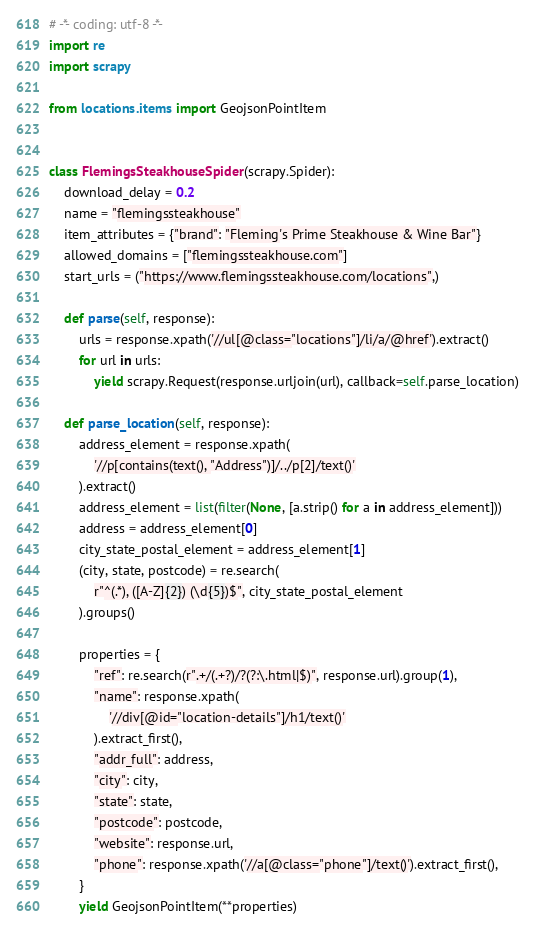<code> <loc_0><loc_0><loc_500><loc_500><_Python_># -*- coding: utf-8 -*-
import re
import scrapy

from locations.items import GeojsonPointItem


class FlemingsSteakhouseSpider(scrapy.Spider):
    download_delay = 0.2
    name = "flemingssteakhouse"
    item_attributes = {"brand": "Fleming's Prime Steakhouse & Wine Bar"}
    allowed_domains = ["flemingssteakhouse.com"]
    start_urls = ("https://www.flemingssteakhouse.com/locations",)

    def parse(self, response):
        urls = response.xpath('//ul[@class="locations"]/li/a/@href').extract()
        for url in urls:
            yield scrapy.Request(response.urljoin(url), callback=self.parse_location)

    def parse_location(self, response):
        address_element = response.xpath(
            '//p[contains(text(), "Address")]/../p[2]/text()'
        ).extract()
        address_element = list(filter(None, [a.strip() for a in address_element]))
        address = address_element[0]
        city_state_postal_element = address_element[1]
        (city, state, postcode) = re.search(
            r"^(.*), ([A-Z]{2}) (\d{5})$", city_state_postal_element
        ).groups()

        properties = {
            "ref": re.search(r".+/(.+?)/?(?:\.html|$)", response.url).group(1),
            "name": response.xpath(
                '//div[@id="location-details"]/h1/text()'
            ).extract_first(),
            "addr_full": address,
            "city": city,
            "state": state,
            "postcode": postcode,
            "website": response.url,
            "phone": response.xpath('//a[@class="phone"]/text()').extract_first(),
        }
        yield GeojsonPointItem(**properties)
</code> 